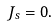Convert formula to latex. <formula><loc_0><loc_0><loc_500><loc_500>J _ { s } = 0 .</formula> 